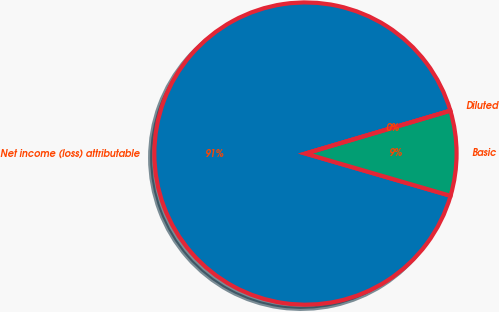<chart> <loc_0><loc_0><loc_500><loc_500><pie_chart><fcel>Net income (loss) attributable<fcel>Basic<fcel>Diluted<nl><fcel>90.91%<fcel>9.09%<fcel>0.0%<nl></chart> 